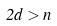Convert formula to latex. <formula><loc_0><loc_0><loc_500><loc_500>2 d > n</formula> 